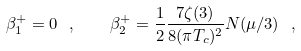<formula> <loc_0><loc_0><loc_500><loc_500>\beta _ { 1 } ^ { + } = 0 \ , \quad \beta _ { 2 } ^ { + } = \frac { 1 } { 2 } \frac { 7 \zeta ( 3 ) } { 8 ( \pi T _ { c } ) ^ { 2 } } N ( \mu / 3 ) \ ,</formula> 